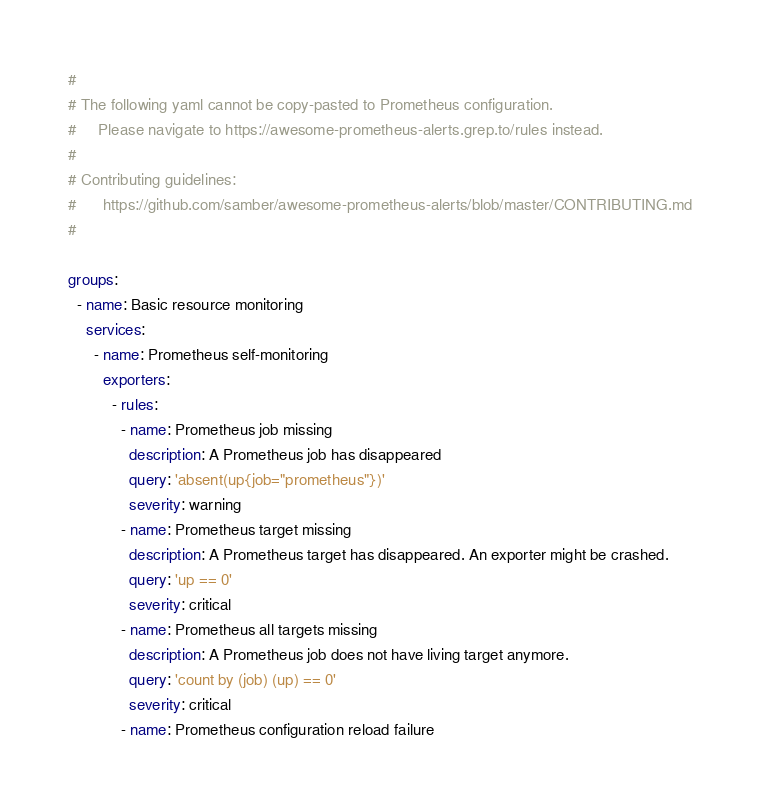<code> <loc_0><loc_0><loc_500><loc_500><_YAML_>
#
# The following yaml cannot be copy-pasted to Prometheus configuration.
#     Please navigate to https://awesome-prometheus-alerts.grep.to/rules instead.
#
# Contributing guidelines:
#      https://github.com/samber/awesome-prometheus-alerts/blob/master/CONTRIBUTING.md
#

groups:
  - name: Basic resource monitoring
    services:
      - name: Prometheus self-monitoring
        exporters:
          - rules:
            - name: Prometheus job missing
              description: A Prometheus job has disappeared
              query: 'absent(up{job="prometheus"})'
              severity: warning
            - name: Prometheus target missing
              description: A Prometheus target has disappeared. An exporter might be crashed.
              query: 'up == 0'
              severity: critical
            - name: Prometheus all targets missing
              description: A Prometheus job does not have living target anymore.
              query: 'count by (job) (up) == 0'
              severity: critical
            - name: Prometheus configuration reload failure</code> 